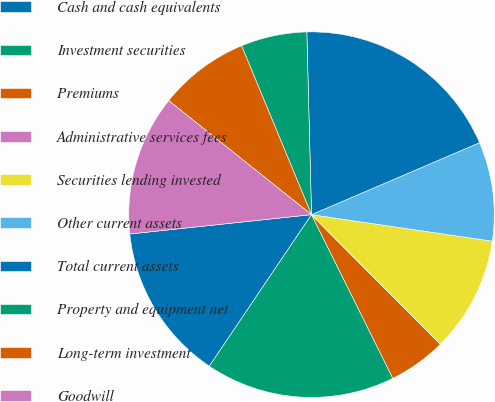Convert chart to OTSL. <chart><loc_0><loc_0><loc_500><loc_500><pie_chart><fcel>Cash and cash equivalents<fcel>Investment securities<fcel>Premiums<fcel>Administrative services fees<fcel>Securities lending invested<fcel>Other current assets<fcel>Total current assets<fcel>Property and equipment net<fcel>Long-term investment<fcel>Goodwill<nl><fcel>13.87%<fcel>16.78%<fcel>5.11%<fcel>0.01%<fcel>10.22%<fcel>8.76%<fcel>18.97%<fcel>5.84%<fcel>8.03%<fcel>12.41%<nl></chart> 